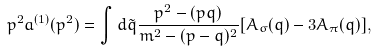Convert formula to latex. <formula><loc_0><loc_0><loc_500><loc_500>p ^ { 2 } a ^ { ( 1 ) } ( p ^ { 2 } ) = \int d \tilde { q } \frac { p ^ { 2 } - ( p q ) } { m ^ { 2 } - ( p - q ) ^ { 2 } } [ A _ { \sigma } ( q ) - 3 A _ { \pi } ( q ) ] ,</formula> 